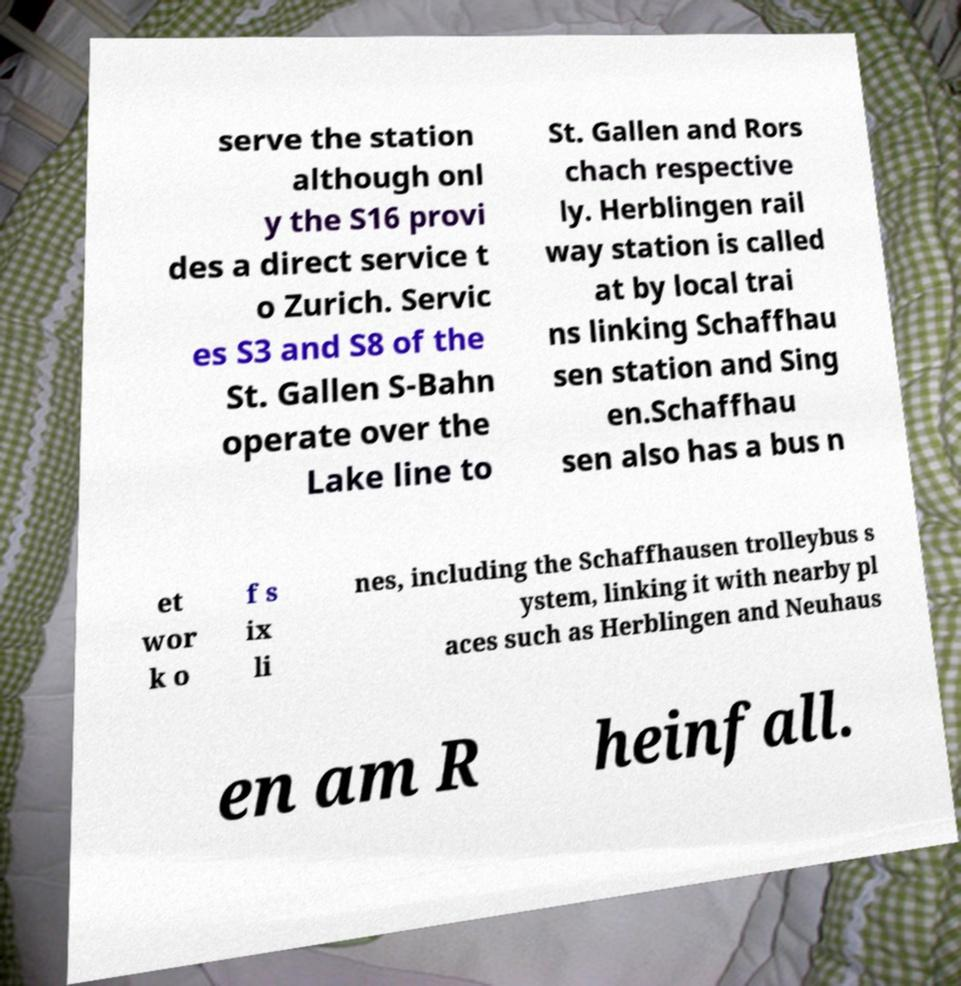Could you assist in decoding the text presented in this image and type it out clearly? serve the station although onl y the S16 provi des a direct service t o Zurich. Servic es S3 and S8 of the St. Gallen S-Bahn operate over the Lake line to St. Gallen and Rors chach respective ly. Herblingen rail way station is called at by local trai ns linking Schaffhau sen station and Sing en.Schaffhau sen also has a bus n et wor k o f s ix li nes, including the Schaffhausen trolleybus s ystem, linking it with nearby pl aces such as Herblingen and Neuhaus en am R heinfall. 